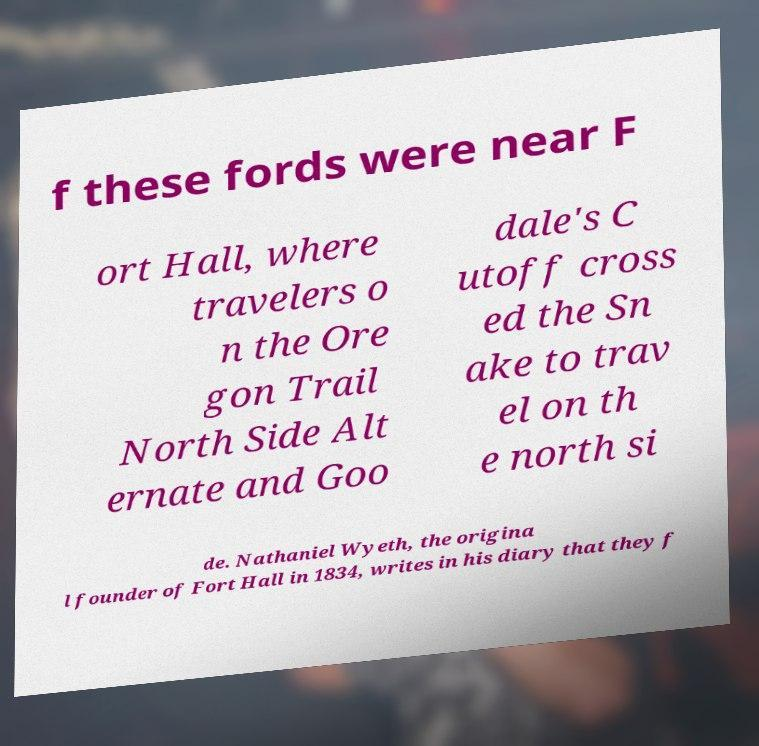Can you accurately transcribe the text from the provided image for me? f these fords were near F ort Hall, where travelers o n the Ore gon Trail North Side Alt ernate and Goo dale's C utoff cross ed the Sn ake to trav el on th e north si de. Nathaniel Wyeth, the origina l founder of Fort Hall in 1834, writes in his diary that they f 